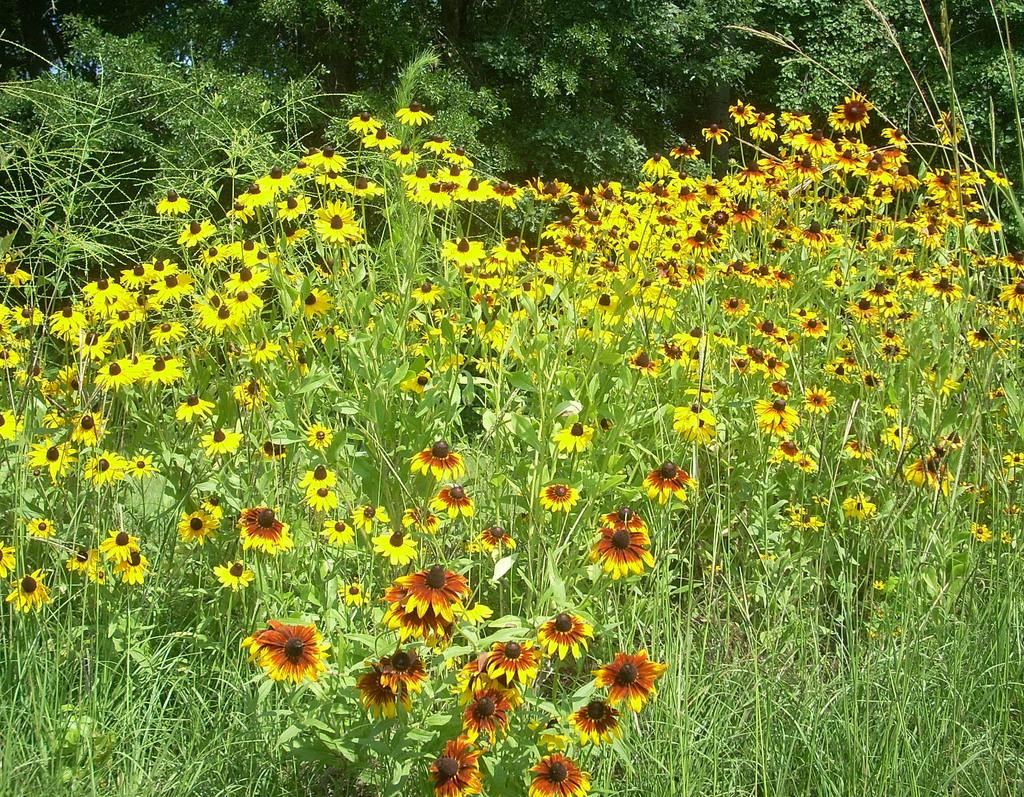What type of plants can be seen in the image? There are many flower plants in the image. What colors are the flowers? The flowers are in yellow and orange colors. What can be seen in the background of the image? There are many trees in the background of the image. How many steps are required to process the flowers in the image? There is no indication in the image that the flowers are being processed, and therefore no steps can be determined. 